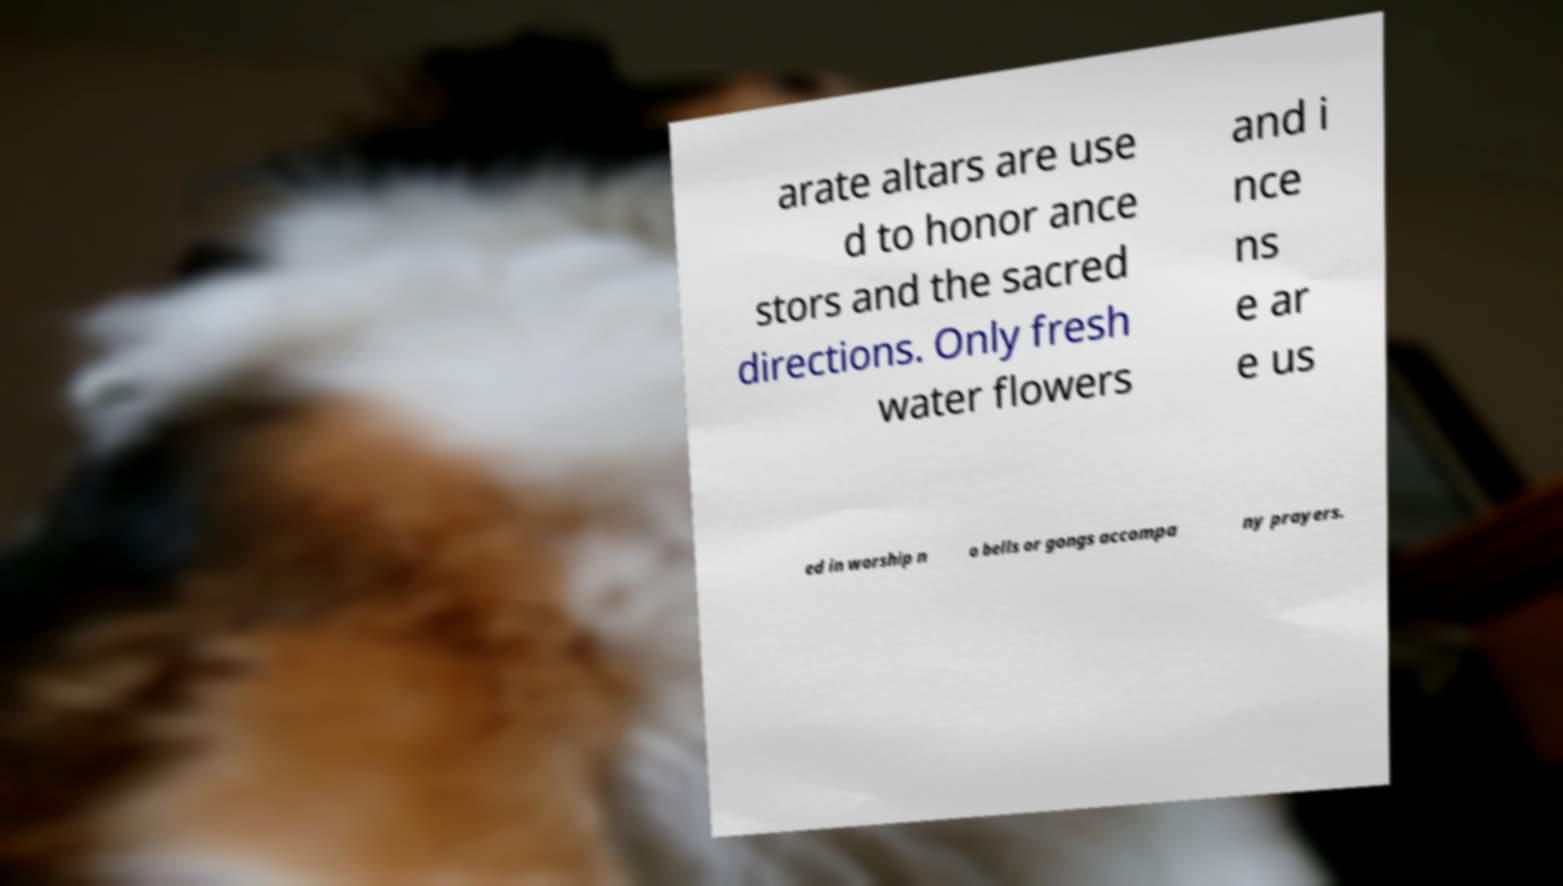Please read and relay the text visible in this image. What does it say? arate altars are use d to honor ance stors and the sacred directions. Only fresh water flowers and i nce ns e ar e us ed in worship n o bells or gongs accompa ny prayers. 